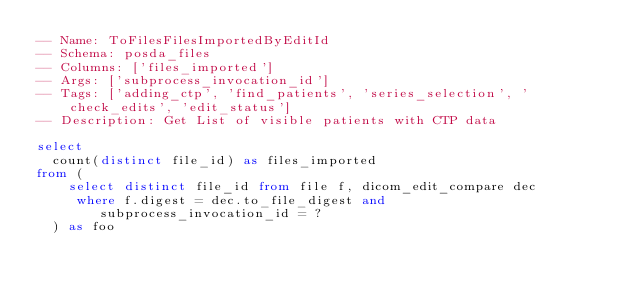Convert code to text. <code><loc_0><loc_0><loc_500><loc_500><_SQL_>-- Name: ToFilesFilesImportedByEditId
-- Schema: posda_files
-- Columns: ['files_imported']
-- Args: ['subprocess_invocation_id']
-- Tags: ['adding_ctp', 'find_patients', 'series_selection', 'check_edits', 'edit_status']
-- Description: Get List of visible patients with CTP data

select
  count(distinct file_id) as files_imported
from (
    select distinct file_id from file f, dicom_edit_compare dec
     where f.digest = dec.to_file_digest and 
        subprocess_invocation_id = ?
  ) as foo
</code> 